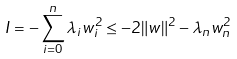<formula> <loc_0><loc_0><loc_500><loc_500>I = - \sum _ { i = 0 } ^ { n } \lambda _ { i } w _ { i } ^ { 2 } \leq - 2 \| w \| ^ { 2 } - \lambda _ { n } w _ { n } ^ { 2 }</formula> 